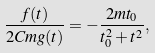<formula> <loc_0><loc_0><loc_500><loc_500>\frac { f ( t ) } { 2 C m g ( t ) } = - \frac { 2 m t _ { 0 } } { t _ { 0 } ^ { 2 } + t ^ { 2 } } ,</formula> 